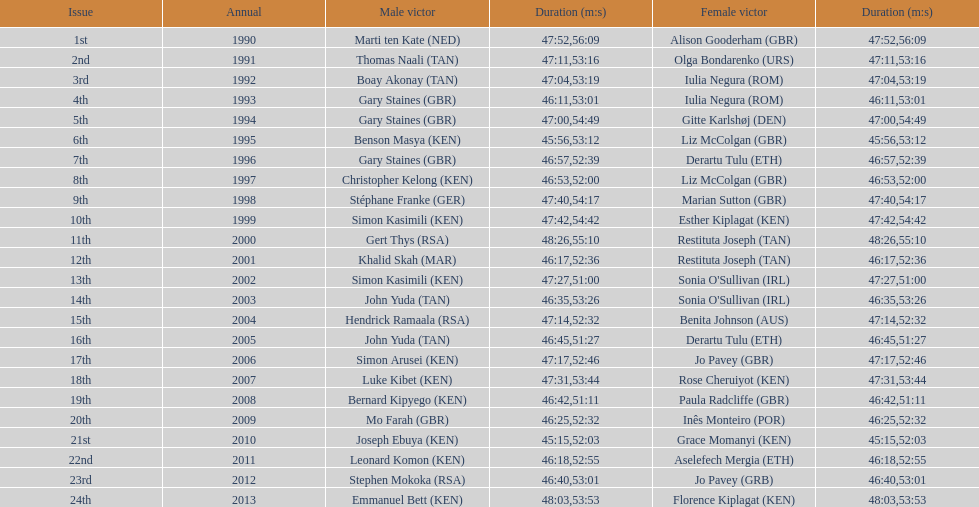In how many instances did men's winners finish the race with a time below 46:58? 12. 